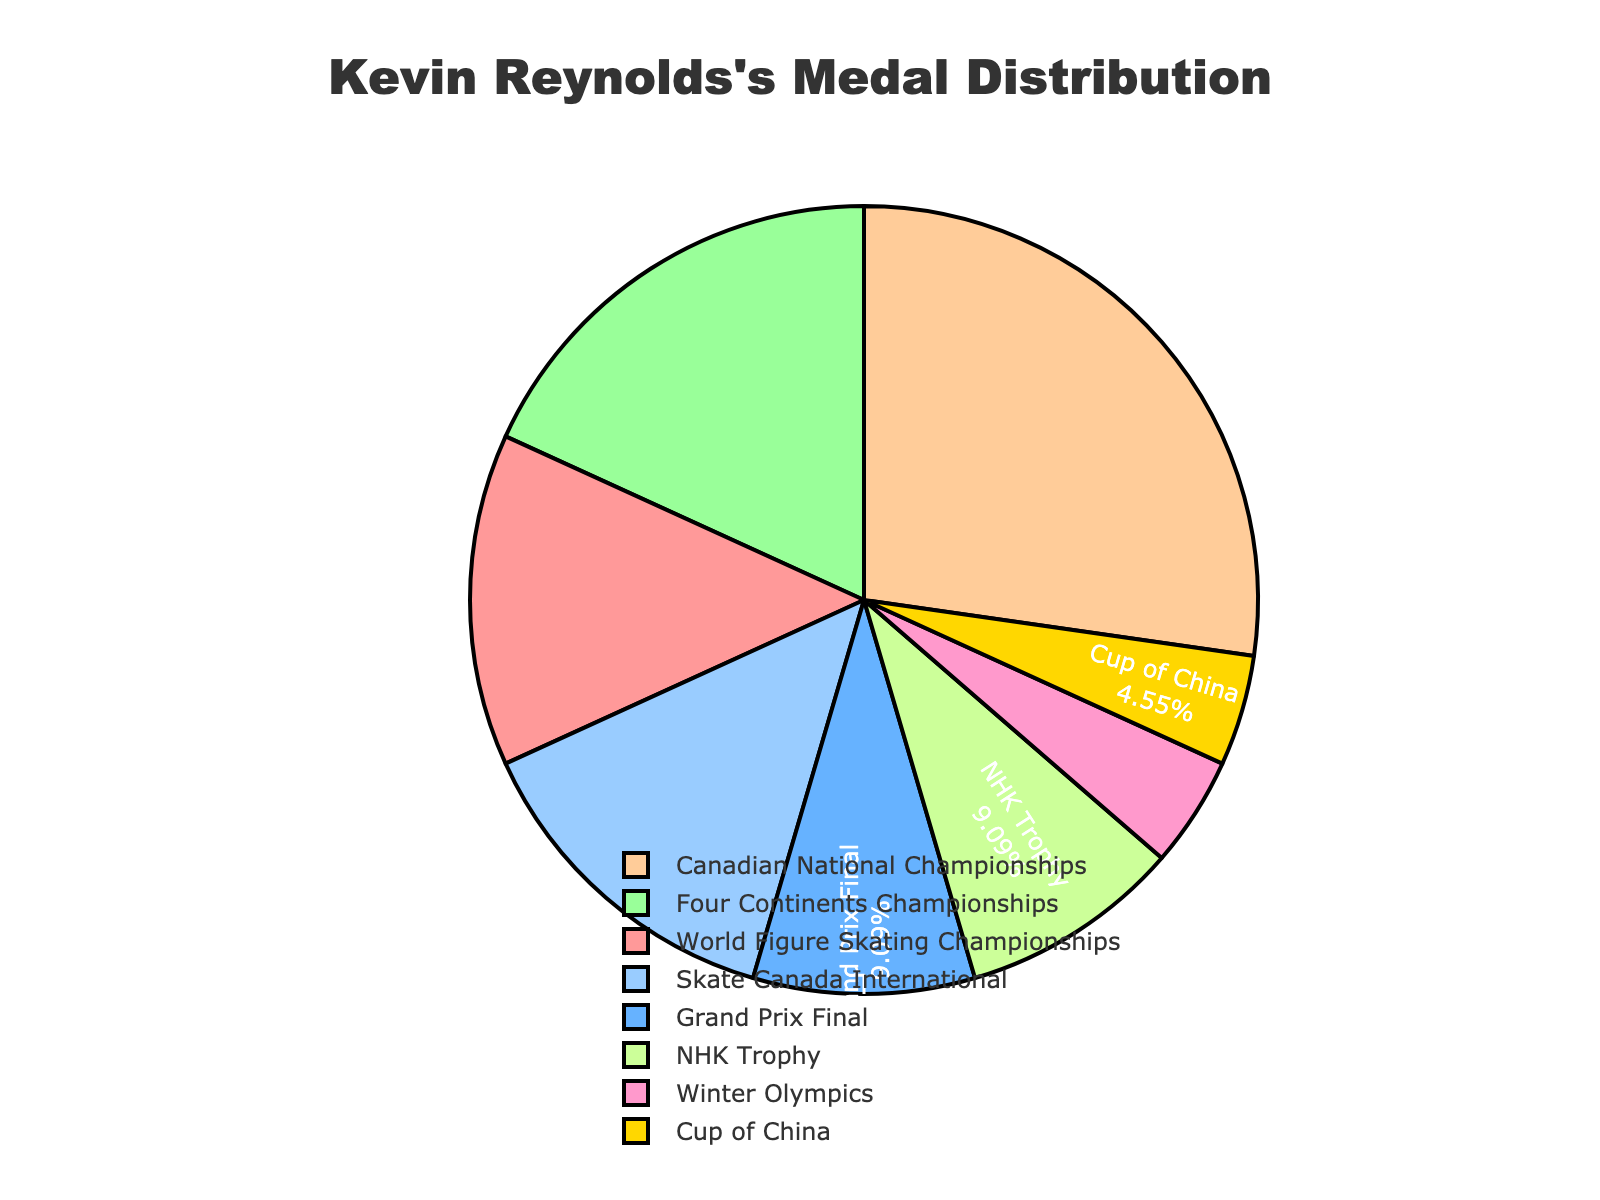What's the competition where Kevin Reynolds has won the most medals? To determine this, look at the portion of the pie chart with the largest slice. The slice representing the Canadian National Championships is the largest, showing that he won the most medals there.
Answer: Canadian National Championships Which competition has an equal number of medals to the NHK Trophy? Examine the pie chart for competitions where the slice size is the same as the NHK Trophy. Both NHK Trophy and Grand Prix Final have two medals each, as indicated by their identical slice sizes.
Answer: Grand Prix Final How many more medals did Kevin Reynolds win at the Four Continents Championships than at the Winter Olympics? From the pie chart, find the slice sizes for Four Continents Championships and Winter Olympics. Four Continents Championships has 4 medals and Winter Olympics has 1. Subtract the latter from the former: 4 - 1 = 3.
Answer: 3 Which competition awarded Kevin Reynolds a single medal? Locate the smallest slices in the pie chart, as they represent competitions with fewer medals. The Cup of China slice is labeled with one medal.
Answer: Cup of China What percentage of medals did Kevin Reynolds win at Skate Canada International? Locate the slice for Skate Canada International and check its percentage label on the pie chart. It should list both the name and the percentage directly.
Answer: 14% How do the total medals for World Figure Skating Championships and Skate Canada International compare to the total medals for Four Continents Championships? Add the medals for World Figure Skating Championships (3) and Skate Canada International (3), then compare this sum of 6 to the Four Continents Championships (4). 6 > 4.
Answer: 6 vs. 4 Which competition slices are depicted in similar colors of green in the pie chart? Inspect the colors of the slices carefully. Both the Four Continents Championships and NHK Trophy slices are depicted in close shades of green.
Answer: Four Continents Championships and NHK Trophy What's the combined percentage of medals won in Grand Prix Final and NHK Trophy competitions? Find the percentages for both the Grand Prix Final and NHK Trophy on the pie chart. Combine them: If the Grand Prix Final is 10% and NHK Trophy is 10%, the total is 20%.
Answer: 20% How do the Winter Olympics medals compare in number to the Grand Prix Final medals? Look at the slice sizes and their labels. Winter Olympics has 1 medal and Grand Prix Final has 2 medals. Winter Olympics has fewer medals.
Answer: Fewer 